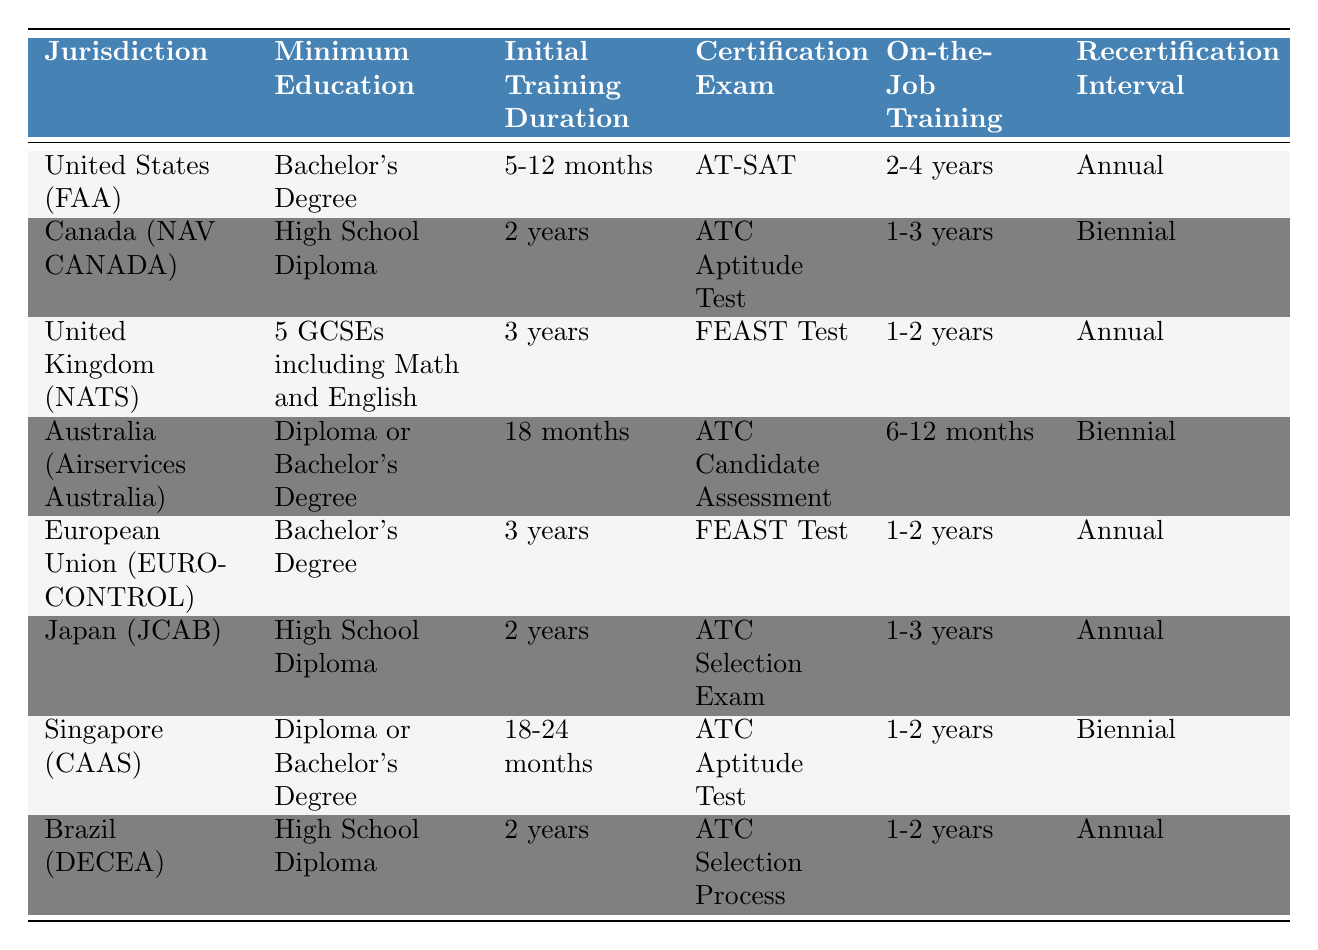What is the minimum education requirement for air traffic controllers in the United States? The table lists the minimum education requirement for the United States (FAA) as a Bachelor's Degree.
Answer: Bachelor's Degree How long is the initial training duration in Canada? The table indicates that the initial training duration in Canada (NAV CANADA) is 2 years.
Answer: 2 years Which jurisdictions require a High School Diploma as the minimum education? By examining the table, it can be seen that Canada (NAV CANADA), Japan (JCAB), and Brazil (DECEA) all require a High School Diploma.
Answer: Canada, Japan, Brazil What is the recertification interval for air traffic controllers in the European Union? The table states that the recertification interval for the European Union (EUROCONTROL) is Annual.
Answer: Annual Is the initial training duration in Australia longer than that in Japan? The initial training duration in Australia is 18 months, while in Japan it is 2 years (equivalent to 24 months). Thus, the duration in Australia is shorter.
Answer: No Which jurisdiction has the longest initial training duration, and what is that duration? Upon reviewing the table, it shows that the United Kingdom (NATS) has an initial training duration of 3 years, which is the longest duration listed.
Answer: United Kingdom (NATS), 3 years How many jurisdictions have a biennial recertification interval? The table shows that Canada (NAV CANADA), Australia (Airservices Australia), and Singapore (CAAS) have a biennial recertification interval, resulting in a total of 3 jurisdictions.
Answer: 3 What is the average initial training duration across all jurisdictions in years? The durations in years are as follows: United States (FAA): 11 months (approx. 0.92 years), Canada: 2 years, UK: 3 years, Australia: 1.5 years, EU: 3 years, Japan: 2 years, Singapore: 1.5 years, Brazil: 2 years. The average is (0.92 + 2 + 3 + 1.5 + 3 + 2 + 1.5 + 2) / 8 = 1.74 years.
Answer: Approximately 1.74 years Is it true that all jurisdictions require on-the-job training? The table indicates that all jurisdictions listed have some requirement for on-the-job training, confirming the statement is true.
Answer: Yes What is the difference in the initial training duration between the United States and Australia? The initial training duration in the United States (FAA) ranges from 5-12 months (averaging approximately 8.5 months) and in Australia is 18 months. The difference is 18 months - 8.5 months = 9.5 months.
Answer: 9.5 months 